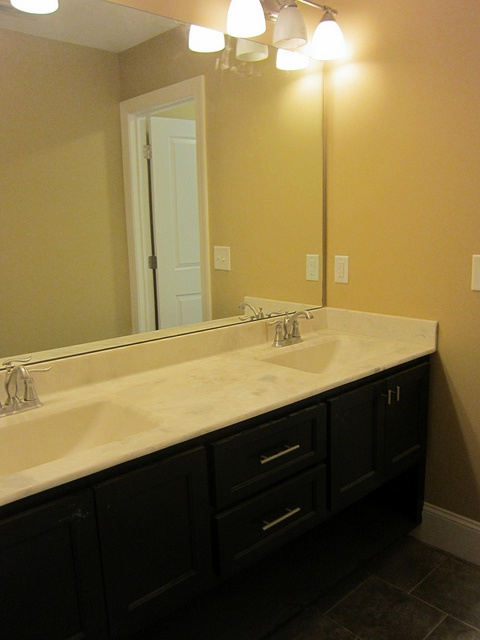Describe the objects in this image and their specific colors. I can see sink in tan tones and sink in tan tones in this image. 